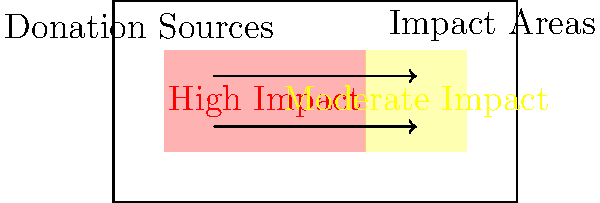As an operation manager for an international Christian-based charity organization, you're tasked with visualizing the global impact of charitable donations. The heat map and flow diagram above represent the distribution and impact of donations worldwide. Based on this visualization, which of the following statements is most accurate?

A) The majority of high-impact areas are concentrated in the Western hemisphere
B) There is an equal distribution of high and moderate impact areas globally
C) The flow of donations is unidirectional from West to East
D) The visualization shows a concentration of high-impact areas with some moderate-impact regions To answer this question, we need to analyze the heat map and flow diagram provided:

1. Heat map analysis:
   - The red area (left side) represents high-impact regions
   - The yellow area (right side) represents moderate-impact regions
   - The red area is larger than the yellow area, indicating more high-impact regions

2. Flow diagram analysis:
   - Arrows are bidirectional, showing flow in both directions
   - This suggests that donations and impact are not limited to one direction

3. Distribution of impact:
   - High-impact areas (red) are concentrated but not exclusive to one hemisphere
   - Moderate-impact areas (yellow) are present but smaller in comparison

4. Evaluating the options:
   A) Incorrect: The map doesn't show hemispheres, and high-impact areas are not exclusively in one area
   B) Incorrect: The distribution is not equal; there are more high-impact than moderate-impact areas
   C) Incorrect: The flow is bidirectional, not unidirectional
   D) Correct: This accurately describes the visualization, showing a concentration of high-impact areas with some moderate-impact regions

Based on this analysis, the most accurate statement is option D.
Answer: D 